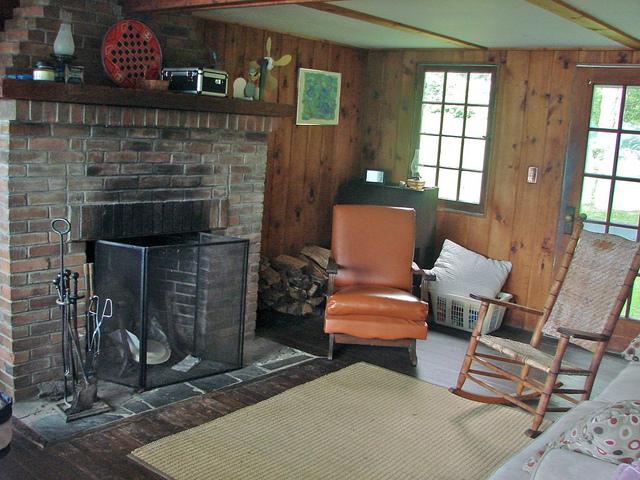What is the brick structure called?
Concise answer only. Fireplace. The black areas on the brick are evidence of what?
Be succinct. Fire. Are the rocking chairs old?
Be succinct. Yes. 